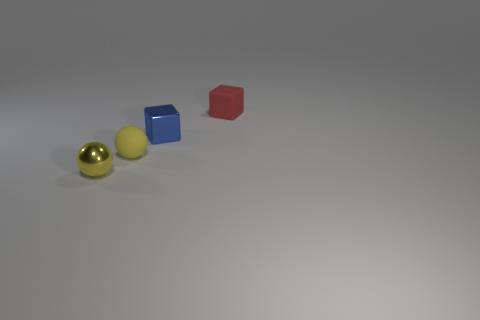Is there another ball that has the same color as the tiny metal ball?
Keep it short and to the point. Yes. Does the red block have the same material as the tiny blue object?
Offer a very short reply. No. There is a sphere that is on the right side of the tiny yellow object that is to the left of the rubber object on the left side of the matte block; what is its color?
Your answer should be compact. Yellow. What is the shape of the red rubber object?
Offer a terse response. Cube. There is a rubber ball; is it the same color as the shiny sphere on the left side of the tiny blue shiny cube?
Your response must be concise. Yes. Are there an equal number of small yellow metallic things to the right of the tiny yellow matte sphere and large yellow metal balls?
Your response must be concise. Yes. How many yellow metal spheres have the same size as the yellow matte ball?
Give a very brief answer. 1. Is there a blue shiny object?
Your answer should be very brief. Yes. Is the shape of the small rubber thing in front of the small metal cube the same as the matte thing that is behind the blue metallic thing?
Offer a terse response. No. What number of large objects are either red blocks or blue shiny things?
Offer a very short reply. 0. 